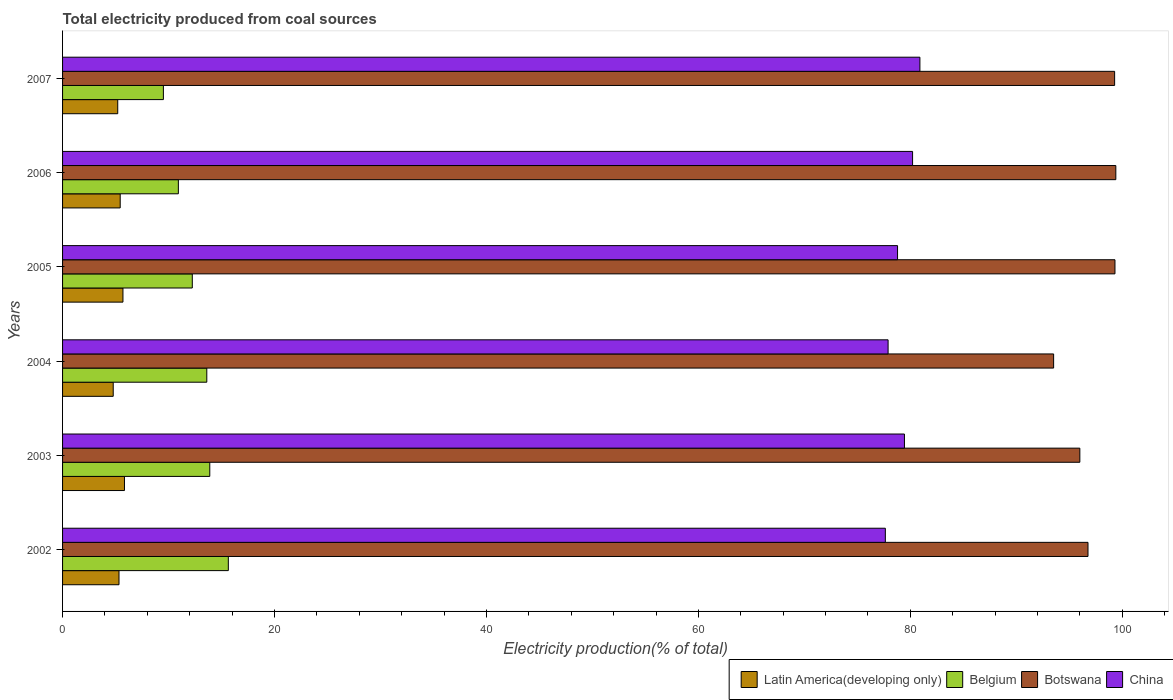How many groups of bars are there?
Your answer should be compact. 6. Are the number of bars on each tick of the Y-axis equal?
Make the answer very short. Yes. What is the label of the 5th group of bars from the top?
Give a very brief answer. 2003. In how many cases, is the number of bars for a given year not equal to the number of legend labels?
Offer a very short reply. 0. What is the total electricity produced in Botswana in 2002?
Give a very brief answer. 96.76. Across all years, what is the maximum total electricity produced in Latin America(developing only)?
Give a very brief answer. 5.84. Across all years, what is the minimum total electricity produced in Latin America(developing only)?
Give a very brief answer. 4.78. In which year was the total electricity produced in China minimum?
Offer a very short reply. 2002. What is the total total electricity produced in Latin America(developing only) in the graph?
Your response must be concise. 32.29. What is the difference between the total electricity produced in Belgium in 2002 and that in 2007?
Provide a short and direct response. 6.13. What is the difference between the total electricity produced in Latin America(developing only) in 2004 and the total electricity produced in Belgium in 2003?
Keep it short and to the point. -9.11. What is the average total electricity produced in Latin America(developing only) per year?
Ensure brevity in your answer.  5.38. In the year 2006, what is the difference between the total electricity produced in Botswana and total electricity produced in China?
Give a very brief answer. 19.18. In how many years, is the total electricity produced in Belgium greater than 60 %?
Your answer should be very brief. 0. What is the ratio of the total electricity produced in Latin America(developing only) in 2004 to that in 2007?
Your response must be concise. 0.92. What is the difference between the highest and the second highest total electricity produced in Belgium?
Your response must be concise. 1.75. What is the difference between the highest and the lowest total electricity produced in Belgium?
Provide a succinct answer. 6.13. Is the sum of the total electricity produced in Botswana in 2005 and 2007 greater than the maximum total electricity produced in Latin America(developing only) across all years?
Your answer should be very brief. Yes. What does the 1st bar from the top in 2002 represents?
Your response must be concise. China. What does the 1st bar from the bottom in 2002 represents?
Make the answer very short. Latin America(developing only). How many bars are there?
Keep it short and to the point. 24. Are all the bars in the graph horizontal?
Offer a terse response. Yes. How many years are there in the graph?
Keep it short and to the point. 6. Does the graph contain grids?
Your answer should be compact. No. How many legend labels are there?
Offer a terse response. 4. How are the legend labels stacked?
Offer a terse response. Horizontal. What is the title of the graph?
Offer a terse response. Total electricity produced from coal sources. Does "South Africa" appear as one of the legend labels in the graph?
Provide a succinct answer. No. What is the label or title of the Y-axis?
Your answer should be very brief. Years. What is the Electricity production(% of total) of Latin America(developing only) in 2002?
Give a very brief answer. 5.33. What is the Electricity production(% of total) of Belgium in 2002?
Provide a short and direct response. 15.64. What is the Electricity production(% of total) in Botswana in 2002?
Offer a terse response. 96.76. What is the Electricity production(% of total) of China in 2002?
Ensure brevity in your answer.  77.64. What is the Electricity production(% of total) in Latin America(developing only) in 2003?
Make the answer very short. 5.84. What is the Electricity production(% of total) in Belgium in 2003?
Ensure brevity in your answer.  13.89. What is the Electricity production(% of total) of Botswana in 2003?
Your answer should be very brief. 95.99. What is the Electricity production(% of total) in China in 2003?
Offer a very short reply. 79.44. What is the Electricity production(% of total) of Latin America(developing only) in 2004?
Offer a terse response. 4.78. What is the Electricity production(% of total) of Belgium in 2004?
Keep it short and to the point. 13.61. What is the Electricity production(% of total) of Botswana in 2004?
Your answer should be compact. 93.52. What is the Electricity production(% of total) of China in 2004?
Provide a succinct answer. 77.9. What is the Electricity production(% of total) of Latin America(developing only) in 2005?
Provide a short and direct response. 5.7. What is the Electricity production(% of total) in Belgium in 2005?
Your answer should be compact. 12.24. What is the Electricity production(% of total) in Botswana in 2005?
Provide a short and direct response. 99.31. What is the Electricity production(% of total) in China in 2005?
Keep it short and to the point. 78.79. What is the Electricity production(% of total) in Latin America(developing only) in 2006?
Your answer should be very brief. 5.44. What is the Electricity production(% of total) of Belgium in 2006?
Offer a very short reply. 10.93. What is the Electricity production(% of total) of Botswana in 2006?
Make the answer very short. 99.39. What is the Electricity production(% of total) of China in 2006?
Make the answer very short. 80.21. What is the Electricity production(% of total) of Latin America(developing only) in 2007?
Your response must be concise. 5.21. What is the Electricity production(% of total) in Belgium in 2007?
Give a very brief answer. 9.51. What is the Electricity production(% of total) of Botswana in 2007?
Ensure brevity in your answer.  99.28. What is the Electricity production(% of total) in China in 2007?
Provide a short and direct response. 80.9. Across all years, what is the maximum Electricity production(% of total) in Latin America(developing only)?
Give a very brief answer. 5.84. Across all years, what is the maximum Electricity production(% of total) of Belgium?
Your response must be concise. 15.64. Across all years, what is the maximum Electricity production(% of total) of Botswana?
Make the answer very short. 99.39. Across all years, what is the maximum Electricity production(% of total) of China?
Your answer should be compact. 80.9. Across all years, what is the minimum Electricity production(% of total) of Latin America(developing only)?
Give a very brief answer. 4.78. Across all years, what is the minimum Electricity production(% of total) in Belgium?
Give a very brief answer. 9.51. Across all years, what is the minimum Electricity production(% of total) in Botswana?
Provide a succinct answer. 93.52. Across all years, what is the minimum Electricity production(% of total) of China?
Offer a terse response. 77.64. What is the total Electricity production(% of total) in Latin America(developing only) in the graph?
Your response must be concise. 32.29. What is the total Electricity production(% of total) in Belgium in the graph?
Give a very brief answer. 75.83. What is the total Electricity production(% of total) in Botswana in the graph?
Offer a very short reply. 584.25. What is the total Electricity production(% of total) of China in the graph?
Your answer should be very brief. 474.89. What is the difference between the Electricity production(% of total) of Latin America(developing only) in 2002 and that in 2003?
Make the answer very short. -0.51. What is the difference between the Electricity production(% of total) in Belgium in 2002 and that in 2003?
Offer a terse response. 1.75. What is the difference between the Electricity production(% of total) in Botswana in 2002 and that in 2003?
Your answer should be very brief. 0.77. What is the difference between the Electricity production(% of total) in China in 2002 and that in 2003?
Offer a terse response. -1.8. What is the difference between the Electricity production(% of total) of Latin America(developing only) in 2002 and that in 2004?
Provide a succinct answer. 0.55. What is the difference between the Electricity production(% of total) of Belgium in 2002 and that in 2004?
Offer a very short reply. 2.03. What is the difference between the Electricity production(% of total) in Botswana in 2002 and that in 2004?
Your answer should be compact. 3.24. What is the difference between the Electricity production(% of total) of China in 2002 and that in 2004?
Offer a very short reply. -0.26. What is the difference between the Electricity production(% of total) in Latin America(developing only) in 2002 and that in 2005?
Provide a succinct answer. -0.37. What is the difference between the Electricity production(% of total) of Belgium in 2002 and that in 2005?
Provide a succinct answer. 3.4. What is the difference between the Electricity production(% of total) in Botswana in 2002 and that in 2005?
Keep it short and to the point. -2.54. What is the difference between the Electricity production(% of total) of China in 2002 and that in 2005?
Keep it short and to the point. -1.15. What is the difference between the Electricity production(% of total) in Latin America(developing only) in 2002 and that in 2006?
Your answer should be compact. -0.11. What is the difference between the Electricity production(% of total) of Belgium in 2002 and that in 2006?
Ensure brevity in your answer.  4.72. What is the difference between the Electricity production(% of total) in Botswana in 2002 and that in 2006?
Provide a succinct answer. -2.63. What is the difference between the Electricity production(% of total) in China in 2002 and that in 2006?
Provide a succinct answer. -2.57. What is the difference between the Electricity production(% of total) of Latin America(developing only) in 2002 and that in 2007?
Your answer should be compact. 0.12. What is the difference between the Electricity production(% of total) in Belgium in 2002 and that in 2007?
Make the answer very short. 6.13. What is the difference between the Electricity production(% of total) in Botswana in 2002 and that in 2007?
Make the answer very short. -2.51. What is the difference between the Electricity production(% of total) of China in 2002 and that in 2007?
Keep it short and to the point. -3.26. What is the difference between the Electricity production(% of total) in Latin America(developing only) in 2003 and that in 2004?
Provide a short and direct response. 1.06. What is the difference between the Electricity production(% of total) in Belgium in 2003 and that in 2004?
Your answer should be compact. 0.28. What is the difference between the Electricity production(% of total) of Botswana in 2003 and that in 2004?
Provide a succinct answer. 2.47. What is the difference between the Electricity production(% of total) of China in 2003 and that in 2004?
Provide a short and direct response. 1.54. What is the difference between the Electricity production(% of total) in Latin America(developing only) in 2003 and that in 2005?
Offer a terse response. 0.14. What is the difference between the Electricity production(% of total) of Belgium in 2003 and that in 2005?
Your answer should be very brief. 1.65. What is the difference between the Electricity production(% of total) in Botswana in 2003 and that in 2005?
Offer a very short reply. -3.31. What is the difference between the Electricity production(% of total) in China in 2003 and that in 2005?
Offer a very short reply. 0.65. What is the difference between the Electricity production(% of total) of Latin America(developing only) in 2003 and that in 2006?
Make the answer very short. 0.4. What is the difference between the Electricity production(% of total) of Belgium in 2003 and that in 2006?
Offer a very short reply. 2.97. What is the difference between the Electricity production(% of total) in Botswana in 2003 and that in 2006?
Your answer should be very brief. -3.4. What is the difference between the Electricity production(% of total) in China in 2003 and that in 2006?
Your answer should be very brief. -0.77. What is the difference between the Electricity production(% of total) in Latin America(developing only) in 2003 and that in 2007?
Provide a short and direct response. 0.63. What is the difference between the Electricity production(% of total) in Belgium in 2003 and that in 2007?
Ensure brevity in your answer.  4.38. What is the difference between the Electricity production(% of total) in Botswana in 2003 and that in 2007?
Your answer should be compact. -3.28. What is the difference between the Electricity production(% of total) of China in 2003 and that in 2007?
Offer a terse response. -1.46. What is the difference between the Electricity production(% of total) in Latin America(developing only) in 2004 and that in 2005?
Ensure brevity in your answer.  -0.92. What is the difference between the Electricity production(% of total) of Belgium in 2004 and that in 2005?
Your response must be concise. 1.37. What is the difference between the Electricity production(% of total) of Botswana in 2004 and that in 2005?
Keep it short and to the point. -5.79. What is the difference between the Electricity production(% of total) of China in 2004 and that in 2005?
Give a very brief answer. -0.89. What is the difference between the Electricity production(% of total) in Latin America(developing only) in 2004 and that in 2006?
Provide a short and direct response. -0.66. What is the difference between the Electricity production(% of total) of Belgium in 2004 and that in 2006?
Your response must be concise. 2.68. What is the difference between the Electricity production(% of total) in Botswana in 2004 and that in 2006?
Offer a very short reply. -5.87. What is the difference between the Electricity production(% of total) of China in 2004 and that in 2006?
Your answer should be compact. -2.31. What is the difference between the Electricity production(% of total) of Latin America(developing only) in 2004 and that in 2007?
Make the answer very short. -0.43. What is the difference between the Electricity production(% of total) of Belgium in 2004 and that in 2007?
Offer a very short reply. 4.1. What is the difference between the Electricity production(% of total) of Botswana in 2004 and that in 2007?
Your answer should be very brief. -5.76. What is the difference between the Electricity production(% of total) of China in 2004 and that in 2007?
Keep it short and to the point. -3. What is the difference between the Electricity production(% of total) in Latin America(developing only) in 2005 and that in 2006?
Your response must be concise. 0.26. What is the difference between the Electricity production(% of total) of Belgium in 2005 and that in 2006?
Offer a terse response. 1.32. What is the difference between the Electricity production(% of total) in Botswana in 2005 and that in 2006?
Your answer should be compact. -0.08. What is the difference between the Electricity production(% of total) in China in 2005 and that in 2006?
Ensure brevity in your answer.  -1.42. What is the difference between the Electricity production(% of total) in Latin America(developing only) in 2005 and that in 2007?
Offer a very short reply. 0.49. What is the difference between the Electricity production(% of total) of Belgium in 2005 and that in 2007?
Your answer should be compact. 2.73. What is the difference between the Electricity production(% of total) of Botswana in 2005 and that in 2007?
Offer a very short reply. 0.03. What is the difference between the Electricity production(% of total) in China in 2005 and that in 2007?
Your response must be concise. -2.11. What is the difference between the Electricity production(% of total) of Latin America(developing only) in 2006 and that in 2007?
Give a very brief answer. 0.23. What is the difference between the Electricity production(% of total) in Belgium in 2006 and that in 2007?
Keep it short and to the point. 1.41. What is the difference between the Electricity production(% of total) of Botswana in 2006 and that in 2007?
Provide a short and direct response. 0.11. What is the difference between the Electricity production(% of total) in China in 2006 and that in 2007?
Provide a succinct answer. -0.69. What is the difference between the Electricity production(% of total) in Latin America(developing only) in 2002 and the Electricity production(% of total) in Belgium in 2003?
Your answer should be very brief. -8.57. What is the difference between the Electricity production(% of total) of Latin America(developing only) in 2002 and the Electricity production(% of total) of Botswana in 2003?
Give a very brief answer. -90.67. What is the difference between the Electricity production(% of total) of Latin America(developing only) in 2002 and the Electricity production(% of total) of China in 2003?
Provide a succinct answer. -74.12. What is the difference between the Electricity production(% of total) of Belgium in 2002 and the Electricity production(% of total) of Botswana in 2003?
Your answer should be very brief. -80.35. What is the difference between the Electricity production(% of total) in Belgium in 2002 and the Electricity production(% of total) in China in 2003?
Your response must be concise. -63.8. What is the difference between the Electricity production(% of total) in Botswana in 2002 and the Electricity production(% of total) in China in 2003?
Your response must be concise. 17.32. What is the difference between the Electricity production(% of total) of Latin America(developing only) in 2002 and the Electricity production(% of total) of Belgium in 2004?
Your answer should be very brief. -8.28. What is the difference between the Electricity production(% of total) of Latin America(developing only) in 2002 and the Electricity production(% of total) of Botswana in 2004?
Offer a very short reply. -88.19. What is the difference between the Electricity production(% of total) of Latin America(developing only) in 2002 and the Electricity production(% of total) of China in 2004?
Offer a very short reply. -72.57. What is the difference between the Electricity production(% of total) in Belgium in 2002 and the Electricity production(% of total) in Botswana in 2004?
Your answer should be very brief. -77.88. What is the difference between the Electricity production(% of total) of Belgium in 2002 and the Electricity production(% of total) of China in 2004?
Give a very brief answer. -62.26. What is the difference between the Electricity production(% of total) of Botswana in 2002 and the Electricity production(% of total) of China in 2004?
Make the answer very short. 18.86. What is the difference between the Electricity production(% of total) in Latin America(developing only) in 2002 and the Electricity production(% of total) in Belgium in 2005?
Offer a very short reply. -6.92. What is the difference between the Electricity production(% of total) of Latin America(developing only) in 2002 and the Electricity production(% of total) of Botswana in 2005?
Your answer should be compact. -93.98. What is the difference between the Electricity production(% of total) of Latin America(developing only) in 2002 and the Electricity production(% of total) of China in 2005?
Your answer should be compact. -73.47. What is the difference between the Electricity production(% of total) of Belgium in 2002 and the Electricity production(% of total) of Botswana in 2005?
Your answer should be compact. -83.67. What is the difference between the Electricity production(% of total) in Belgium in 2002 and the Electricity production(% of total) in China in 2005?
Your answer should be very brief. -63.15. What is the difference between the Electricity production(% of total) of Botswana in 2002 and the Electricity production(% of total) of China in 2005?
Provide a succinct answer. 17.97. What is the difference between the Electricity production(% of total) in Latin America(developing only) in 2002 and the Electricity production(% of total) in Belgium in 2006?
Your answer should be compact. -5.6. What is the difference between the Electricity production(% of total) of Latin America(developing only) in 2002 and the Electricity production(% of total) of Botswana in 2006?
Offer a terse response. -94.06. What is the difference between the Electricity production(% of total) of Latin America(developing only) in 2002 and the Electricity production(% of total) of China in 2006?
Keep it short and to the point. -74.88. What is the difference between the Electricity production(% of total) in Belgium in 2002 and the Electricity production(% of total) in Botswana in 2006?
Offer a terse response. -83.75. What is the difference between the Electricity production(% of total) in Belgium in 2002 and the Electricity production(% of total) in China in 2006?
Offer a very short reply. -64.57. What is the difference between the Electricity production(% of total) of Botswana in 2002 and the Electricity production(% of total) of China in 2006?
Your answer should be very brief. 16.55. What is the difference between the Electricity production(% of total) of Latin America(developing only) in 2002 and the Electricity production(% of total) of Belgium in 2007?
Your response must be concise. -4.19. What is the difference between the Electricity production(% of total) of Latin America(developing only) in 2002 and the Electricity production(% of total) of Botswana in 2007?
Provide a short and direct response. -93.95. What is the difference between the Electricity production(% of total) of Latin America(developing only) in 2002 and the Electricity production(% of total) of China in 2007?
Your answer should be very brief. -75.58. What is the difference between the Electricity production(% of total) of Belgium in 2002 and the Electricity production(% of total) of Botswana in 2007?
Keep it short and to the point. -83.63. What is the difference between the Electricity production(% of total) in Belgium in 2002 and the Electricity production(% of total) in China in 2007?
Offer a terse response. -65.26. What is the difference between the Electricity production(% of total) in Botswana in 2002 and the Electricity production(% of total) in China in 2007?
Keep it short and to the point. 15.86. What is the difference between the Electricity production(% of total) in Latin America(developing only) in 2003 and the Electricity production(% of total) in Belgium in 2004?
Provide a short and direct response. -7.77. What is the difference between the Electricity production(% of total) of Latin America(developing only) in 2003 and the Electricity production(% of total) of Botswana in 2004?
Provide a short and direct response. -87.68. What is the difference between the Electricity production(% of total) of Latin America(developing only) in 2003 and the Electricity production(% of total) of China in 2004?
Offer a terse response. -72.06. What is the difference between the Electricity production(% of total) in Belgium in 2003 and the Electricity production(% of total) in Botswana in 2004?
Make the answer very short. -79.63. What is the difference between the Electricity production(% of total) in Belgium in 2003 and the Electricity production(% of total) in China in 2004?
Offer a terse response. -64.01. What is the difference between the Electricity production(% of total) in Botswana in 2003 and the Electricity production(% of total) in China in 2004?
Your answer should be very brief. 18.09. What is the difference between the Electricity production(% of total) of Latin America(developing only) in 2003 and the Electricity production(% of total) of Belgium in 2005?
Make the answer very short. -6.4. What is the difference between the Electricity production(% of total) of Latin America(developing only) in 2003 and the Electricity production(% of total) of Botswana in 2005?
Give a very brief answer. -93.47. What is the difference between the Electricity production(% of total) of Latin America(developing only) in 2003 and the Electricity production(% of total) of China in 2005?
Make the answer very short. -72.95. What is the difference between the Electricity production(% of total) of Belgium in 2003 and the Electricity production(% of total) of Botswana in 2005?
Your answer should be very brief. -85.42. What is the difference between the Electricity production(% of total) in Belgium in 2003 and the Electricity production(% of total) in China in 2005?
Keep it short and to the point. -64.9. What is the difference between the Electricity production(% of total) in Botswana in 2003 and the Electricity production(% of total) in China in 2005?
Keep it short and to the point. 17.2. What is the difference between the Electricity production(% of total) of Latin America(developing only) in 2003 and the Electricity production(% of total) of Belgium in 2006?
Your response must be concise. -5.09. What is the difference between the Electricity production(% of total) in Latin America(developing only) in 2003 and the Electricity production(% of total) in Botswana in 2006?
Your response must be concise. -93.55. What is the difference between the Electricity production(% of total) in Latin America(developing only) in 2003 and the Electricity production(% of total) in China in 2006?
Your answer should be very brief. -74.37. What is the difference between the Electricity production(% of total) of Belgium in 2003 and the Electricity production(% of total) of Botswana in 2006?
Offer a terse response. -85.5. What is the difference between the Electricity production(% of total) of Belgium in 2003 and the Electricity production(% of total) of China in 2006?
Keep it short and to the point. -66.32. What is the difference between the Electricity production(% of total) in Botswana in 2003 and the Electricity production(% of total) in China in 2006?
Keep it short and to the point. 15.78. What is the difference between the Electricity production(% of total) of Latin America(developing only) in 2003 and the Electricity production(% of total) of Belgium in 2007?
Ensure brevity in your answer.  -3.67. What is the difference between the Electricity production(% of total) in Latin America(developing only) in 2003 and the Electricity production(% of total) in Botswana in 2007?
Make the answer very short. -93.43. What is the difference between the Electricity production(% of total) in Latin America(developing only) in 2003 and the Electricity production(% of total) in China in 2007?
Give a very brief answer. -75.06. What is the difference between the Electricity production(% of total) of Belgium in 2003 and the Electricity production(% of total) of Botswana in 2007?
Provide a succinct answer. -85.38. What is the difference between the Electricity production(% of total) in Belgium in 2003 and the Electricity production(% of total) in China in 2007?
Your response must be concise. -67.01. What is the difference between the Electricity production(% of total) in Botswana in 2003 and the Electricity production(% of total) in China in 2007?
Offer a terse response. 15.09. What is the difference between the Electricity production(% of total) of Latin America(developing only) in 2004 and the Electricity production(% of total) of Belgium in 2005?
Make the answer very short. -7.46. What is the difference between the Electricity production(% of total) of Latin America(developing only) in 2004 and the Electricity production(% of total) of Botswana in 2005?
Keep it short and to the point. -94.53. What is the difference between the Electricity production(% of total) of Latin America(developing only) in 2004 and the Electricity production(% of total) of China in 2005?
Give a very brief answer. -74.01. What is the difference between the Electricity production(% of total) in Belgium in 2004 and the Electricity production(% of total) in Botswana in 2005?
Ensure brevity in your answer.  -85.7. What is the difference between the Electricity production(% of total) in Belgium in 2004 and the Electricity production(% of total) in China in 2005?
Give a very brief answer. -65.18. What is the difference between the Electricity production(% of total) in Botswana in 2004 and the Electricity production(% of total) in China in 2005?
Your answer should be compact. 14.73. What is the difference between the Electricity production(% of total) of Latin America(developing only) in 2004 and the Electricity production(% of total) of Belgium in 2006?
Provide a short and direct response. -6.15. What is the difference between the Electricity production(% of total) in Latin America(developing only) in 2004 and the Electricity production(% of total) in Botswana in 2006?
Keep it short and to the point. -94.61. What is the difference between the Electricity production(% of total) in Latin America(developing only) in 2004 and the Electricity production(% of total) in China in 2006?
Keep it short and to the point. -75.43. What is the difference between the Electricity production(% of total) of Belgium in 2004 and the Electricity production(% of total) of Botswana in 2006?
Offer a very short reply. -85.78. What is the difference between the Electricity production(% of total) in Belgium in 2004 and the Electricity production(% of total) in China in 2006?
Provide a succinct answer. -66.6. What is the difference between the Electricity production(% of total) of Botswana in 2004 and the Electricity production(% of total) of China in 2006?
Your answer should be compact. 13.31. What is the difference between the Electricity production(% of total) of Latin America(developing only) in 2004 and the Electricity production(% of total) of Belgium in 2007?
Your response must be concise. -4.73. What is the difference between the Electricity production(% of total) in Latin America(developing only) in 2004 and the Electricity production(% of total) in Botswana in 2007?
Keep it short and to the point. -94.5. What is the difference between the Electricity production(% of total) in Latin America(developing only) in 2004 and the Electricity production(% of total) in China in 2007?
Provide a succinct answer. -76.12. What is the difference between the Electricity production(% of total) of Belgium in 2004 and the Electricity production(% of total) of Botswana in 2007?
Your answer should be compact. -85.66. What is the difference between the Electricity production(% of total) of Belgium in 2004 and the Electricity production(% of total) of China in 2007?
Provide a short and direct response. -67.29. What is the difference between the Electricity production(% of total) of Botswana in 2004 and the Electricity production(% of total) of China in 2007?
Give a very brief answer. 12.62. What is the difference between the Electricity production(% of total) in Latin America(developing only) in 2005 and the Electricity production(% of total) in Belgium in 2006?
Offer a terse response. -5.23. What is the difference between the Electricity production(% of total) in Latin America(developing only) in 2005 and the Electricity production(% of total) in Botswana in 2006?
Provide a short and direct response. -93.69. What is the difference between the Electricity production(% of total) in Latin America(developing only) in 2005 and the Electricity production(% of total) in China in 2006?
Provide a succinct answer. -74.51. What is the difference between the Electricity production(% of total) of Belgium in 2005 and the Electricity production(% of total) of Botswana in 2006?
Make the answer very short. -87.15. What is the difference between the Electricity production(% of total) in Belgium in 2005 and the Electricity production(% of total) in China in 2006?
Ensure brevity in your answer.  -67.97. What is the difference between the Electricity production(% of total) in Botswana in 2005 and the Electricity production(% of total) in China in 2006?
Your answer should be very brief. 19.1. What is the difference between the Electricity production(% of total) in Latin America(developing only) in 2005 and the Electricity production(% of total) in Belgium in 2007?
Keep it short and to the point. -3.82. What is the difference between the Electricity production(% of total) of Latin America(developing only) in 2005 and the Electricity production(% of total) of Botswana in 2007?
Your answer should be very brief. -93.58. What is the difference between the Electricity production(% of total) of Latin America(developing only) in 2005 and the Electricity production(% of total) of China in 2007?
Keep it short and to the point. -75.2. What is the difference between the Electricity production(% of total) of Belgium in 2005 and the Electricity production(% of total) of Botswana in 2007?
Provide a short and direct response. -87.03. What is the difference between the Electricity production(% of total) of Belgium in 2005 and the Electricity production(% of total) of China in 2007?
Keep it short and to the point. -68.66. What is the difference between the Electricity production(% of total) of Botswana in 2005 and the Electricity production(% of total) of China in 2007?
Provide a short and direct response. 18.41. What is the difference between the Electricity production(% of total) of Latin America(developing only) in 2006 and the Electricity production(% of total) of Belgium in 2007?
Offer a terse response. -4.08. What is the difference between the Electricity production(% of total) of Latin America(developing only) in 2006 and the Electricity production(% of total) of Botswana in 2007?
Give a very brief answer. -93.84. What is the difference between the Electricity production(% of total) of Latin America(developing only) in 2006 and the Electricity production(% of total) of China in 2007?
Your response must be concise. -75.46. What is the difference between the Electricity production(% of total) in Belgium in 2006 and the Electricity production(% of total) in Botswana in 2007?
Give a very brief answer. -88.35. What is the difference between the Electricity production(% of total) of Belgium in 2006 and the Electricity production(% of total) of China in 2007?
Your response must be concise. -69.97. What is the difference between the Electricity production(% of total) in Botswana in 2006 and the Electricity production(% of total) in China in 2007?
Offer a very short reply. 18.49. What is the average Electricity production(% of total) in Latin America(developing only) per year?
Provide a short and direct response. 5.38. What is the average Electricity production(% of total) in Belgium per year?
Offer a very short reply. 12.64. What is the average Electricity production(% of total) in Botswana per year?
Keep it short and to the point. 97.38. What is the average Electricity production(% of total) of China per year?
Ensure brevity in your answer.  79.15. In the year 2002, what is the difference between the Electricity production(% of total) in Latin America(developing only) and Electricity production(% of total) in Belgium?
Offer a very short reply. -10.32. In the year 2002, what is the difference between the Electricity production(% of total) of Latin America(developing only) and Electricity production(% of total) of Botswana?
Your answer should be very brief. -91.44. In the year 2002, what is the difference between the Electricity production(% of total) in Latin America(developing only) and Electricity production(% of total) in China?
Offer a terse response. -72.31. In the year 2002, what is the difference between the Electricity production(% of total) of Belgium and Electricity production(% of total) of Botswana?
Your answer should be very brief. -81.12. In the year 2002, what is the difference between the Electricity production(% of total) of Belgium and Electricity production(% of total) of China?
Ensure brevity in your answer.  -62. In the year 2002, what is the difference between the Electricity production(% of total) of Botswana and Electricity production(% of total) of China?
Provide a succinct answer. 19.12. In the year 2003, what is the difference between the Electricity production(% of total) in Latin America(developing only) and Electricity production(% of total) in Belgium?
Provide a short and direct response. -8.05. In the year 2003, what is the difference between the Electricity production(% of total) in Latin America(developing only) and Electricity production(% of total) in Botswana?
Provide a short and direct response. -90.15. In the year 2003, what is the difference between the Electricity production(% of total) of Latin America(developing only) and Electricity production(% of total) of China?
Your answer should be very brief. -73.6. In the year 2003, what is the difference between the Electricity production(% of total) of Belgium and Electricity production(% of total) of Botswana?
Your answer should be very brief. -82.1. In the year 2003, what is the difference between the Electricity production(% of total) in Belgium and Electricity production(% of total) in China?
Provide a succinct answer. -65.55. In the year 2003, what is the difference between the Electricity production(% of total) of Botswana and Electricity production(% of total) of China?
Your answer should be very brief. 16.55. In the year 2004, what is the difference between the Electricity production(% of total) of Latin America(developing only) and Electricity production(% of total) of Belgium?
Ensure brevity in your answer.  -8.83. In the year 2004, what is the difference between the Electricity production(% of total) in Latin America(developing only) and Electricity production(% of total) in Botswana?
Ensure brevity in your answer.  -88.74. In the year 2004, what is the difference between the Electricity production(% of total) in Latin America(developing only) and Electricity production(% of total) in China?
Your answer should be very brief. -73.12. In the year 2004, what is the difference between the Electricity production(% of total) in Belgium and Electricity production(% of total) in Botswana?
Make the answer very short. -79.91. In the year 2004, what is the difference between the Electricity production(% of total) of Belgium and Electricity production(% of total) of China?
Provide a short and direct response. -64.29. In the year 2004, what is the difference between the Electricity production(% of total) in Botswana and Electricity production(% of total) in China?
Your answer should be very brief. 15.62. In the year 2005, what is the difference between the Electricity production(% of total) of Latin America(developing only) and Electricity production(% of total) of Belgium?
Make the answer very short. -6.54. In the year 2005, what is the difference between the Electricity production(% of total) of Latin America(developing only) and Electricity production(% of total) of Botswana?
Ensure brevity in your answer.  -93.61. In the year 2005, what is the difference between the Electricity production(% of total) in Latin America(developing only) and Electricity production(% of total) in China?
Offer a very short reply. -73.09. In the year 2005, what is the difference between the Electricity production(% of total) of Belgium and Electricity production(% of total) of Botswana?
Your answer should be very brief. -87.07. In the year 2005, what is the difference between the Electricity production(% of total) in Belgium and Electricity production(% of total) in China?
Your response must be concise. -66.55. In the year 2005, what is the difference between the Electricity production(% of total) of Botswana and Electricity production(% of total) of China?
Ensure brevity in your answer.  20.52. In the year 2006, what is the difference between the Electricity production(% of total) of Latin America(developing only) and Electricity production(% of total) of Belgium?
Provide a short and direct response. -5.49. In the year 2006, what is the difference between the Electricity production(% of total) of Latin America(developing only) and Electricity production(% of total) of Botswana?
Ensure brevity in your answer.  -93.95. In the year 2006, what is the difference between the Electricity production(% of total) in Latin America(developing only) and Electricity production(% of total) in China?
Provide a succinct answer. -74.77. In the year 2006, what is the difference between the Electricity production(% of total) of Belgium and Electricity production(% of total) of Botswana?
Make the answer very short. -88.46. In the year 2006, what is the difference between the Electricity production(% of total) of Belgium and Electricity production(% of total) of China?
Your response must be concise. -69.28. In the year 2006, what is the difference between the Electricity production(% of total) of Botswana and Electricity production(% of total) of China?
Keep it short and to the point. 19.18. In the year 2007, what is the difference between the Electricity production(% of total) in Latin America(developing only) and Electricity production(% of total) in Belgium?
Your response must be concise. -4.31. In the year 2007, what is the difference between the Electricity production(% of total) in Latin America(developing only) and Electricity production(% of total) in Botswana?
Make the answer very short. -94.07. In the year 2007, what is the difference between the Electricity production(% of total) of Latin America(developing only) and Electricity production(% of total) of China?
Ensure brevity in your answer.  -75.69. In the year 2007, what is the difference between the Electricity production(% of total) in Belgium and Electricity production(% of total) in Botswana?
Provide a succinct answer. -89.76. In the year 2007, what is the difference between the Electricity production(% of total) in Belgium and Electricity production(% of total) in China?
Ensure brevity in your answer.  -71.39. In the year 2007, what is the difference between the Electricity production(% of total) in Botswana and Electricity production(% of total) in China?
Ensure brevity in your answer.  18.37. What is the ratio of the Electricity production(% of total) of Latin America(developing only) in 2002 to that in 2003?
Ensure brevity in your answer.  0.91. What is the ratio of the Electricity production(% of total) of Belgium in 2002 to that in 2003?
Provide a succinct answer. 1.13. What is the ratio of the Electricity production(% of total) of Botswana in 2002 to that in 2003?
Your answer should be very brief. 1.01. What is the ratio of the Electricity production(% of total) in China in 2002 to that in 2003?
Offer a very short reply. 0.98. What is the ratio of the Electricity production(% of total) of Latin America(developing only) in 2002 to that in 2004?
Offer a very short reply. 1.11. What is the ratio of the Electricity production(% of total) of Belgium in 2002 to that in 2004?
Provide a short and direct response. 1.15. What is the ratio of the Electricity production(% of total) in Botswana in 2002 to that in 2004?
Your response must be concise. 1.03. What is the ratio of the Electricity production(% of total) of China in 2002 to that in 2004?
Your answer should be very brief. 1. What is the ratio of the Electricity production(% of total) of Latin America(developing only) in 2002 to that in 2005?
Give a very brief answer. 0.93. What is the ratio of the Electricity production(% of total) of Belgium in 2002 to that in 2005?
Your answer should be compact. 1.28. What is the ratio of the Electricity production(% of total) of Botswana in 2002 to that in 2005?
Make the answer very short. 0.97. What is the ratio of the Electricity production(% of total) in China in 2002 to that in 2005?
Make the answer very short. 0.99. What is the ratio of the Electricity production(% of total) of Latin America(developing only) in 2002 to that in 2006?
Provide a succinct answer. 0.98. What is the ratio of the Electricity production(% of total) in Belgium in 2002 to that in 2006?
Your response must be concise. 1.43. What is the ratio of the Electricity production(% of total) of Botswana in 2002 to that in 2006?
Ensure brevity in your answer.  0.97. What is the ratio of the Electricity production(% of total) in Belgium in 2002 to that in 2007?
Your answer should be compact. 1.64. What is the ratio of the Electricity production(% of total) of Botswana in 2002 to that in 2007?
Provide a succinct answer. 0.97. What is the ratio of the Electricity production(% of total) of China in 2002 to that in 2007?
Keep it short and to the point. 0.96. What is the ratio of the Electricity production(% of total) of Latin America(developing only) in 2003 to that in 2004?
Give a very brief answer. 1.22. What is the ratio of the Electricity production(% of total) of Belgium in 2003 to that in 2004?
Provide a succinct answer. 1.02. What is the ratio of the Electricity production(% of total) in Botswana in 2003 to that in 2004?
Your answer should be very brief. 1.03. What is the ratio of the Electricity production(% of total) of China in 2003 to that in 2004?
Offer a very short reply. 1.02. What is the ratio of the Electricity production(% of total) of Belgium in 2003 to that in 2005?
Provide a succinct answer. 1.13. What is the ratio of the Electricity production(% of total) of Botswana in 2003 to that in 2005?
Offer a terse response. 0.97. What is the ratio of the Electricity production(% of total) in China in 2003 to that in 2005?
Offer a very short reply. 1.01. What is the ratio of the Electricity production(% of total) of Latin America(developing only) in 2003 to that in 2006?
Offer a very short reply. 1.07. What is the ratio of the Electricity production(% of total) of Belgium in 2003 to that in 2006?
Make the answer very short. 1.27. What is the ratio of the Electricity production(% of total) of Botswana in 2003 to that in 2006?
Your answer should be compact. 0.97. What is the ratio of the Electricity production(% of total) in Latin America(developing only) in 2003 to that in 2007?
Provide a succinct answer. 1.12. What is the ratio of the Electricity production(% of total) of Belgium in 2003 to that in 2007?
Ensure brevity in your answer.  1.46. What is the ratio of the Electricity production(% of total) in Botswana in 2003 to that in 2007?
Provide a short and direct response. 0.97. What is the ratio of the Electricity production(% of total) in Latin America(developing only) in 2004 to that in 2005?
Keep it short and to the point. 0.84. What is the ratio of the Electricity production(% of total) in Belgium in 2004 to that in 2005?
Offer a terse response. 1.11. What is the ratio of the Electricity production(% of total) of Botswana in 2004 to that in 2005?
Ensure brevity in your answer.  0.94. What is the ratio of the Electricity production(% of total) in China in 2004 to that in 2005?
Provide a succinct answer. 0.99. What is the ratio of the Electricity production(% of total) of Latin America(developing only) in 2004 to that in 2006?
Keep it short and to the point. 0.88. What is the ratio of the Electricity production(% of total) of Belgium in 2004 to that in 2006?
Offer a terse response. 1.25. What is the ratio of the Electricity production(% of total) in Botswana in 2004 to that in 2006?
Your answer should be very brief. 0.94. What is the ratio of the Electricity production(% of total) in China in 2004 to that in 2006?
Your answer should be compact. 0.97. What is the ratio of the Electricity production(% of total) in Latin America(developing only) in 2004 to that in 2007?
Your answer should be compact. 0.92. What is the ratio of the Electricity production(% of total) in Belgium in 2004 to that in 2007?
Your response must be concise. 1.43. What is the ratio of the Electricity production(% of total) in Botswana in 2004 to that in 2007?
Your answer should be compact. 0.94. What is the ratio of the Electricity production(% of total) of China in 2004 to that in 2007?
Offer a terse response. 0.96. What is the ratio of the Electricity production(% of total) of Latin America(developing only) in 2005 to that in 2006?
Provide a short and direct response. 1.05. What is the ratio of the Electricity production(% of total) of Belgium in 2005 to that in 2006?
Give a very brief answer. 1.12. What is the ratio of the Electricity production(% of total) in China in 2005 to that in 2006?
Offer a terse response. 0.98. What is the ratio of the Electricity production(% of total) of Latin America(developing only) in 2005 to that in 2007?
Your answer should be very brief. 1.09. What is the ratio of the Electricity production(% of total) in Belgium in 2005 to that in 2007?
Provide a succinct answer. 1.29. What is the ratio of the Electricity production(% of total) of China in 2005 to that in 2007?
Provide a short and direct response. 0.97. What is the ratio of the Electricity production(% of total) in Latin America(developing only) in 2006 to that in 2007?
Your answer should be very brief. 1.04. What is the ratio of the Electricity production(% of total) in Belgium in 2006 to that in 2007?
Your response must be concise. 1.15. What is the difference between the highest and the second highest Electricity production(% of total) of Latin America(developing only)?
Your response must be concise. 0.14. What is the difference between the highest and the second highest Electricity production(% of total) in Belgium?
Your answer should be very brief. 1.75. What is the difference between the highest and the second highest Electricity production(% of total) of Botswana?
Your response must be concise. 0.08. What is the difference between the highest and the second highest Electricity production(% of total) in China?
Provide a succinct answer. 0.69. What is the difference between the highest and the lowest Electricity production(% of total) of Latin America(developing only)?
Provide a short and direct response. 1.06. What is the difference between the highest and the lowest Electricity production(% of total) of Belgium?
Offer a terse response. 6.13. What is the difference between the highest and the lowest Electricity production(% of total) in Botswana?
Your answer should be compact. 5.87. What is the difference between the highest and the lowest Electricity production(% of total) of China?
Keep it short and to the point. 3.26. 